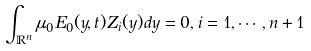Convert formula to latex. <formula><loc_0><loc_0><loc_500><loc_500>\int _ { \mathbb { R } ^ { n } } \mu _ { 0 } E _ { 0 } ( y , t ) Z _ { i } ( y ) d y = 0 , i = 1 , \cdots , n + 1</formula> 